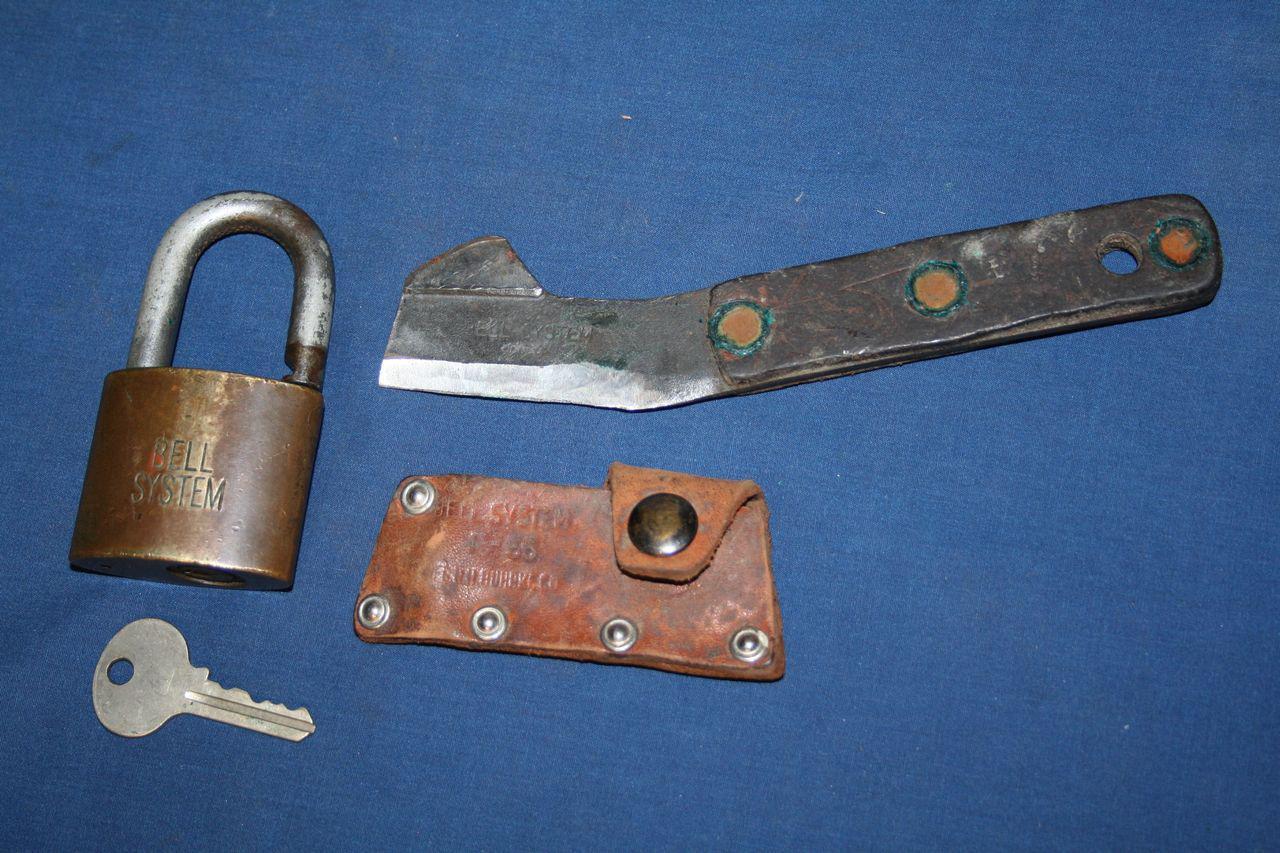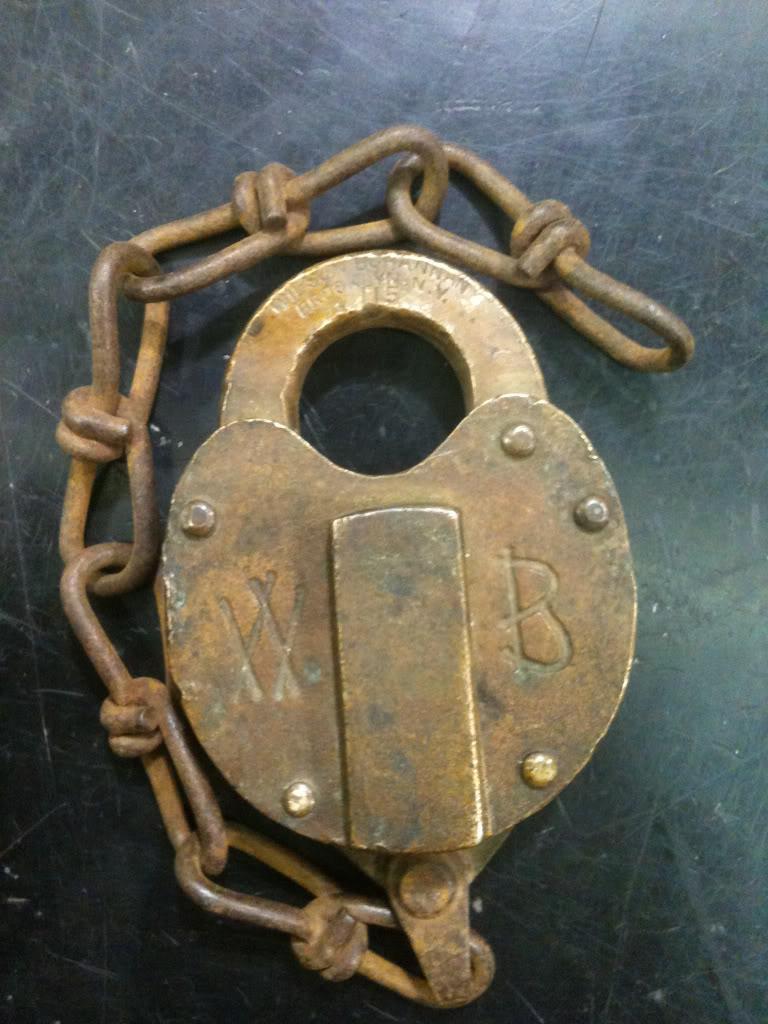The first image is the image on the left, the second image is the image on the right. Analyze the images presented: Is the assertion "A key is in a single lock in the image on the left." valid? Answer yes or no. No. 